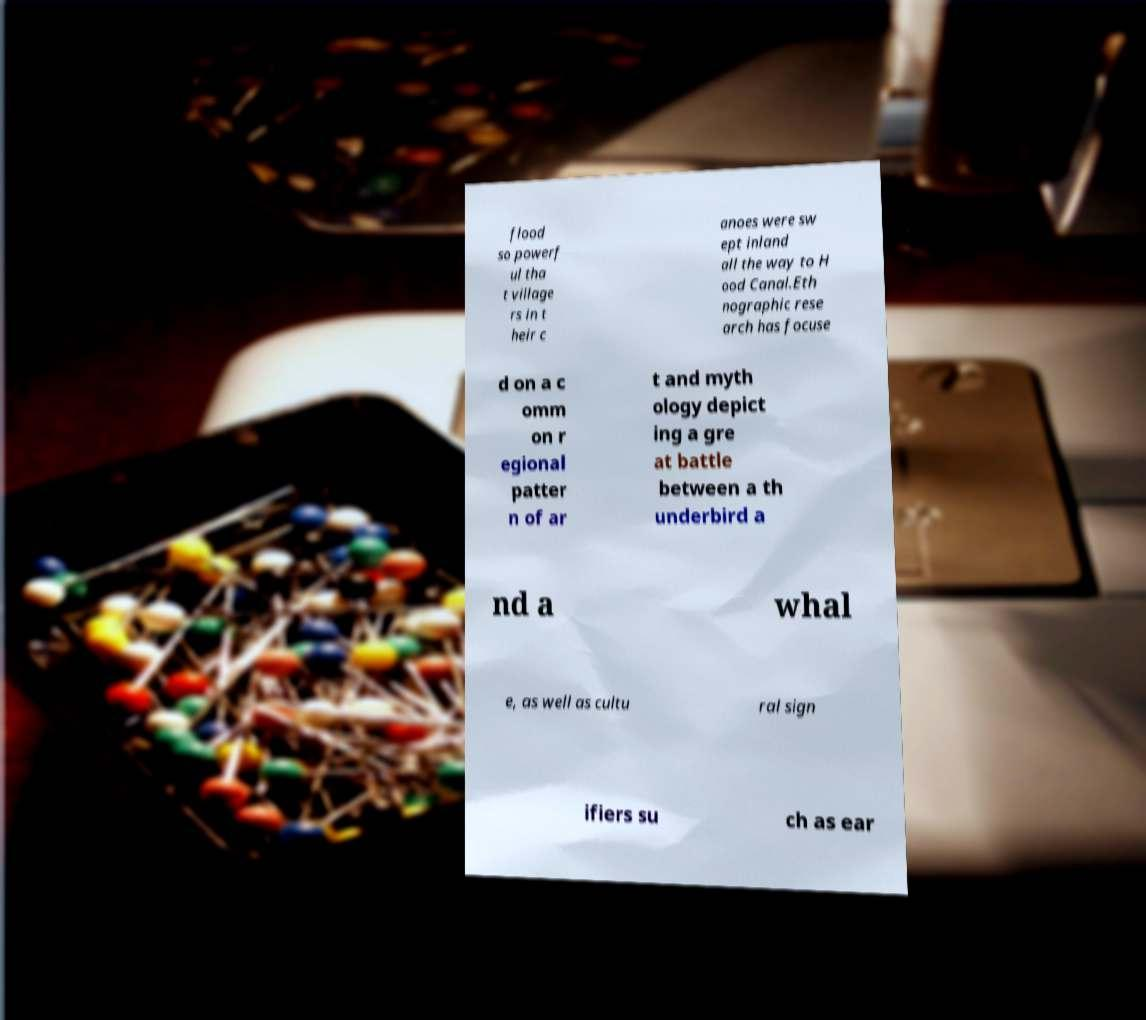Can you read and provide the text displayed in the image?This photo seems to have some interesting text. Can you extract and type it out for me? flood so powerf ul tha t village rs in t heir c anoes were sw ept inland all the way to H ood Canal.Eth nographic rese arch has focuse d on a c omm on r egional patter n of ar t and myth ology depict ing a gre at battle between a th underbird a nd a whal e, as well as cultu ral sign ifiers su ch as ear 